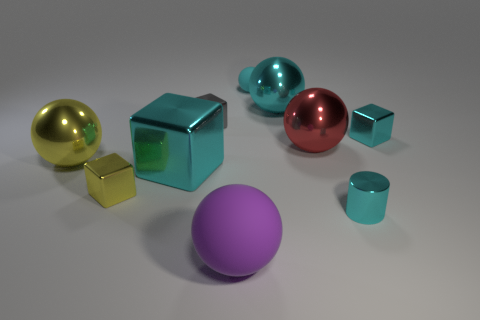Is the material of the large red thing the same as the tiny thing that is on the right side of the small cyan cylinder?
Provide a short and direct response. Yes. What number of things are either large spheres behind the small gray metallic block or tiny spheres that are behind the big cyan shiny ball?
Offer a very short reply. 2. How many other objects are there of the same color as the tiny sphere?
Keep it short and to the point. 4. Are there more purple balls on the right side of the large red object than tiny cyan metallic things that are in front of the tiny gray shiny block?
Provide a short and direct response. No. Is there anything else that is the same size as the yellow ball?
Offer a very short reply. Yes. What number of blocks are either big green metal objects or red shiny objects?
Make the answer very short. 0. How many things are big shiny objects that are in front of the small gray shiny cube or tiny cyan blocks?
Your answer should be compact. 4. There is a tiny cyan thing behind the large cyan metallic thing on the right side of the matte thing behind the small yellow metal object; what shape is it?
Provide a succinct answer. Sphere. What number of other metal things are the same shape as the tiny yellow object?
Your response must be concise. 3. What is the material of the tiny ball that is the same color as the large cube?
Make the answer very short. Rubber. 